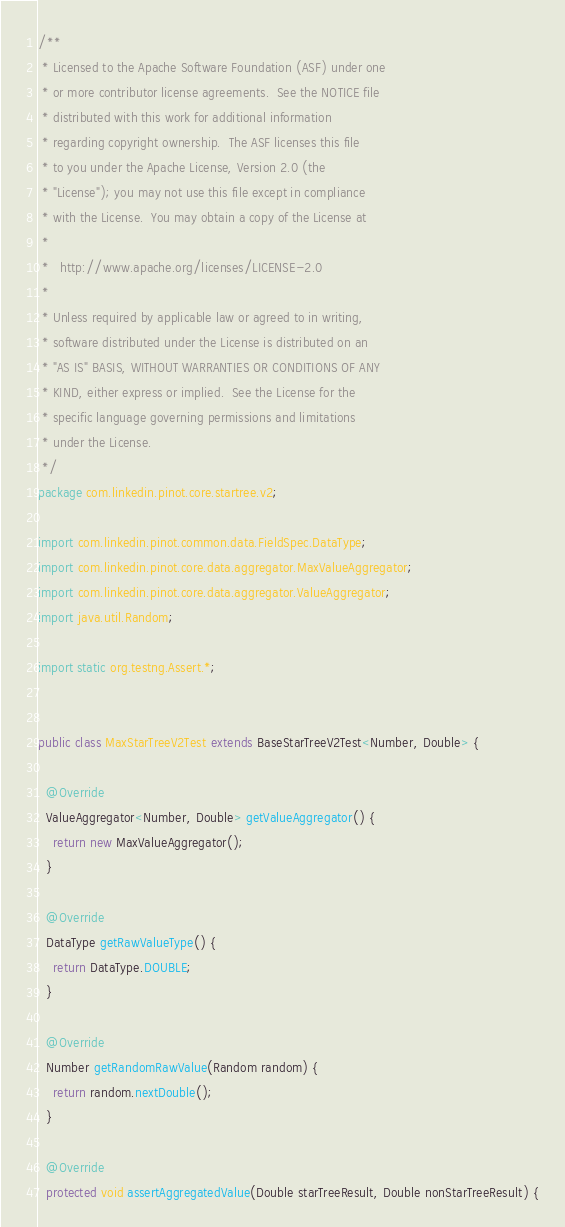Convert code to text. <code><loc_0><loc_0><loc_500><loc_500><_Java_>/**
 * Licensed to the Apache Software Foundation (ASF) under one
 * or more contributor license agreements.  See the NOTICE file
 * distributed with this work for additional information
 * regarding copyright ownership.  The ASF licenses this file
 * to you under the Apache License, Version 2.0 (the
 * "License"); you may not use this file except in compliance
 * with the License.  You may obtain a copy of the License at
 *
 *   http://www.apache.org/licenses/LICENSE-2.0
 *
 * Unless required by applicable law or agreed to in writing,
 * software distributed under the License is distributed on an
 * "AS IS" BASIS, WITHOUT WARRANTIES OR CONDITIONS OF ANY
 * KIND, either express or implied.  See the License for the
 * specific language governing permissions and limitations
 * under the License.
 */
package com.linkedin.pinot.core.startree.v2;

import com.linkedin.pinot.common.data.FieldSpec.DataType;
import com.linkedin.pinot.core.data.aggregator.MaxValueAggregator;
import com.linkedin.pinot.core.data.aggregator.ValueAggregator;
import java.util.Random;

import static org.testng.Assert.*;


public class MaxStarTreeV2Test extends BaseStarTreeV2Test<Number, Double> {

  @Override
  ValueAggregator<Number, Double> getValueAggregator() {
    return new MaxValueAggregator();
  }

  @Override
  DataType getRawValueType() {
    return DataType.DOUBLE;
  }

  @Override
  Number getRandomRawValue(Random random) {
    return random.nextDouble();
  }

  @Override
  protected void assertAggregatedValue(Double starTreeResult, Double nonStarTreeResult) {</code> 